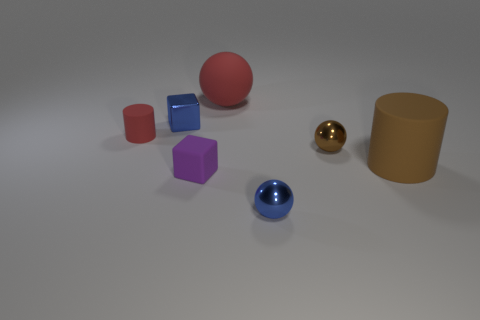How many objects are tiny matte things or tiny red metal cylinders?
Keep it short and to the point. 2. There is a matte cube that is the same size as the blue shiny block; what color is it?
Offer a terse response. Purple. What number of things are large rubber objects that are right of the tiny blue ball or rubber cylinders?
Make the answer very short. 2. What number of other objects are the same size as the blue metallic ball?
Provide a short and direct response. 4. How big is the rubber cylinder that is behind the tiny brown shiny thing?
Keep it short and to the point. Small. There is a small red object that is the same material as the purple cube; what is its shape?
Make the answer very short. Cylinder. Is there anything else that is the same color as the large rubber sphere?
Your answer should be compact. Yes. What is the color of the small metallic sphere behind the matte object that is on the right side of the small brown shiny thing?
Your response must be concise. Brown. How many large things are either purple metallic cylinders or rubber objects?
Provide a short and direct response. 2. What material is the small blue object that is the same shape as the small brown object?
Offer a terse response. Metal. 